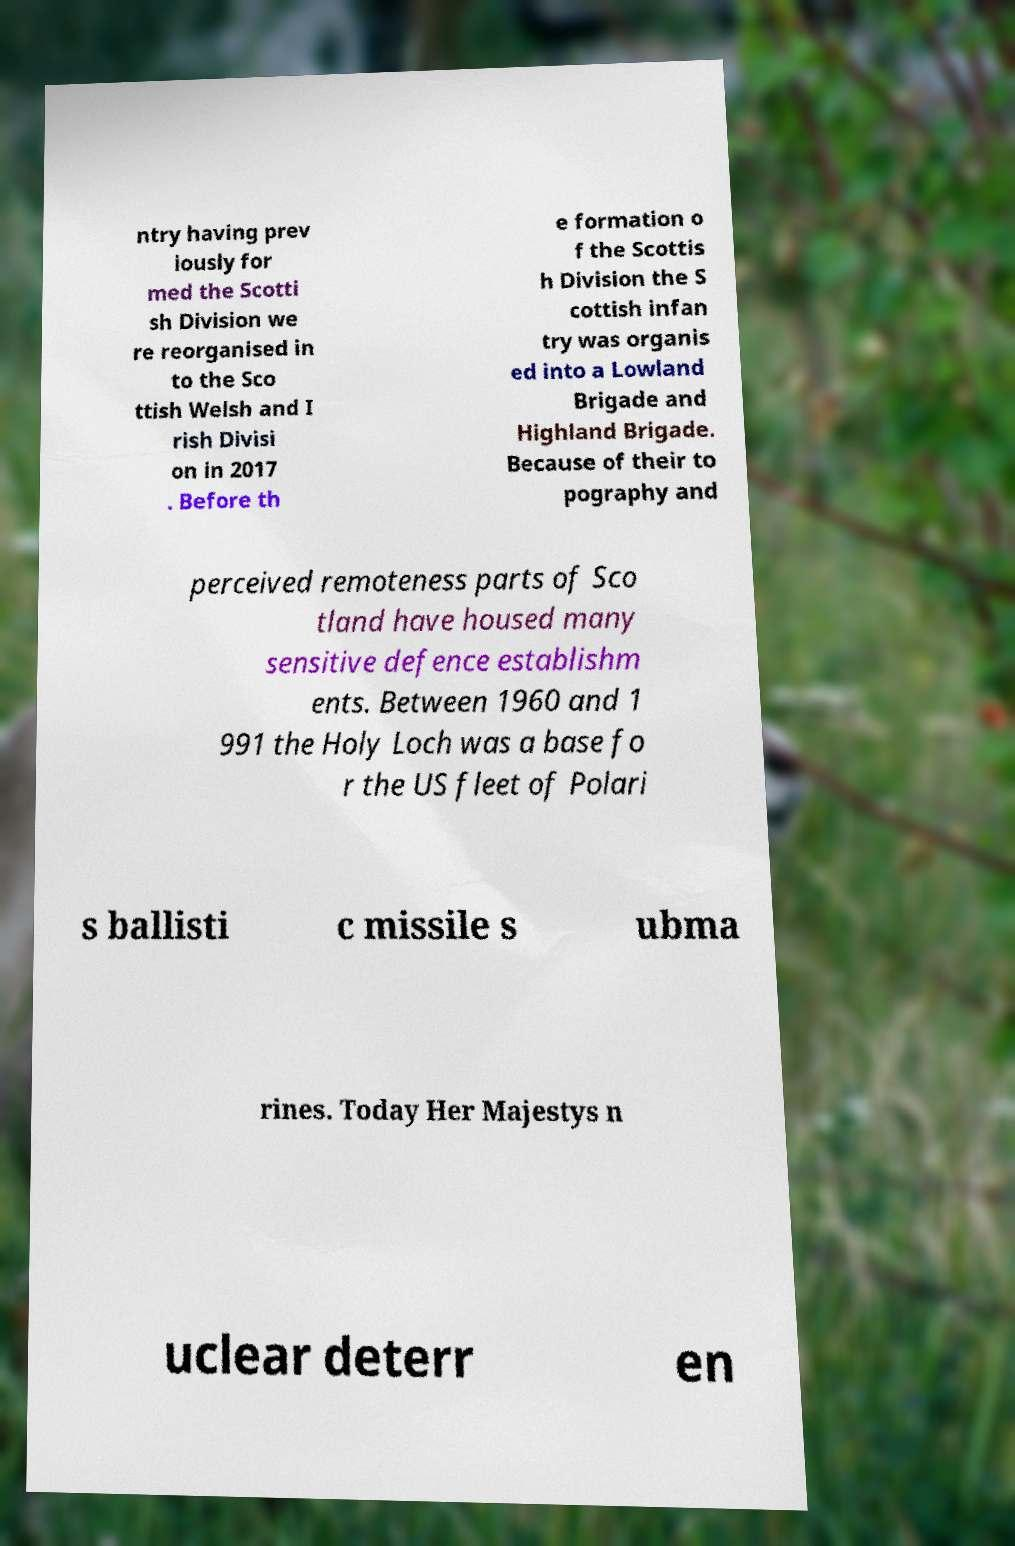Can you accurately transcribe the text from the provided image for me? ntry having prev iously for med the Scotti sh Division we re reorganised in to the Sco ttish Welsh and I rish Divisi on in 2017 . Before th e formation o f the Scottis h Division the S cottish infan try was organis ed into a Lowland Brigade and Highland Brigade. Because of their to pography and perceived remoteness parts of Sco tland have housed many sensitive defence establishm ents. Between 1960 and 1 991 the Holy Loch was a base fo r the US fleet of Polari s ballisti c missile s ubma rines. Today Her Majestys n uclear deterr en 